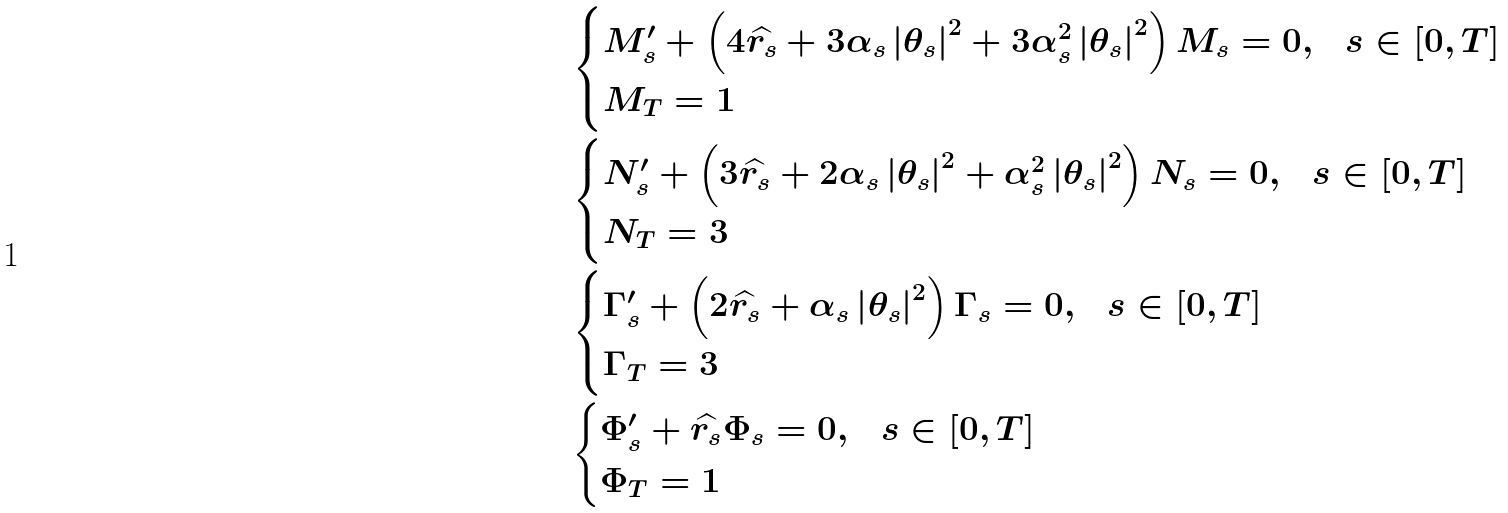Convert formula to latex. <formula><loc_0><loc_0><loc_500><loc_500>& \begin{cases} M _ { s } ^ { \prime } + \left ( 4 \widehat { r _ { s } } + 3 \alpha _ { s } \left | \theta _ { s } \right | ^ { 2 } + 3 \alpha _ { s } ^ { 2 } \left | \theta _ { s } \right | ^ { 2 } \right ) M _ { s } = 0 , & s \in \left [ 0 , T \right ] \\ M _ { T } = 1 \end{cases} \\ & \begin{cases} N _ { s } ^ { \prime } + \left ( 3 \widehat { r _ { s } } + 2 \alpha _ { s } \left | \theta _ { s } \right | ^ { 2 } + \alpha _ { s } ^ { 2 } \left | \theta _ { s } \right | ^ { 2 } \right ) N _ { s } = 0 , & s \in \left [ 0 , T \right ] \\ N _ { T } = 3 \end{cases} \\ & \begin{cases} \Gamma _ { s } ^ { \prime } + \left ( 2 \widehat { r _ { s } } + \alpha _ { s } \left | \theta _ { s } \right | ^ { 2 } \right ) \Gamma _ { s } = 0 , & s \in \left [ 0 , T \right ] \\ \Gamma _ { T } = 3 \end{cases} \\ & \begin{cases} \Phi _ { s } ^ { \prime } + \widehat { r _ { s } } \Phi _ { s } = 0 , & s \in \left [ 0 , T \right ] \\ \Phi _ { T } = 1 \end{cases}</formula> 